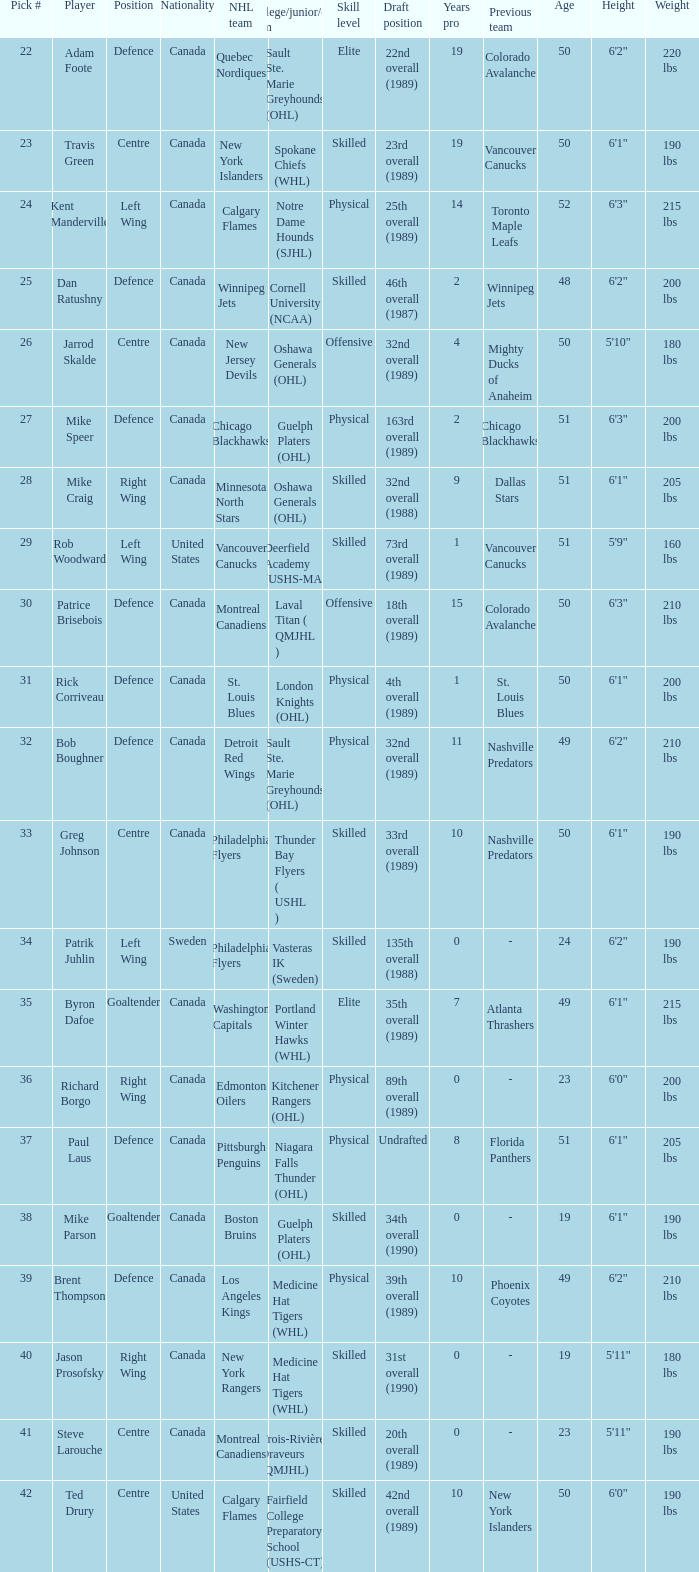Which nhl team chose richard borgo? Edmonton Oilers. 